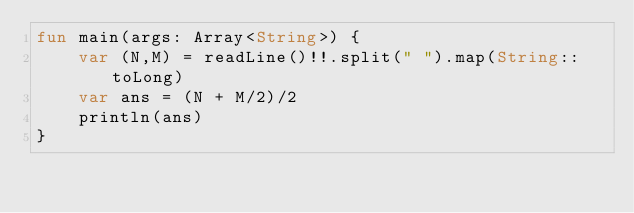Convert code to text. <code><loc_0><loc_0><loc_500><loc_500><_Kotlin_>fun main(args: Array<String>) {
    var (N,M) = readLine()!!.split(" ").map(String::toLong)
    var ans = (N + M/2)/2
    println(ans)
}
</code> 